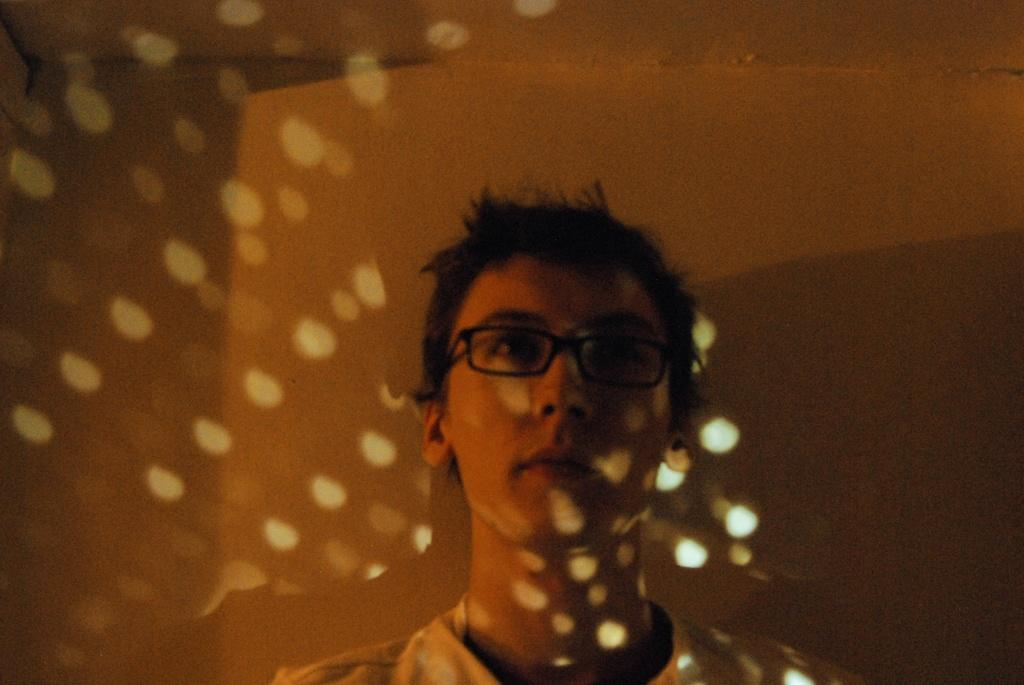Who is present in the image? There is a man in the picture. What is the man wearing in the image? The man is wearing spectacles. What can be seen in the background of the image? There is a wall visible in the background of the picture. What might be the source of the reflection in the image? There appears to be a reflection of lights in the image. What type of suit is the man wearing in the image? The provided facts do not mention a suit; the man is only described as wearing spectacles. How many times does the man turn around in the image? There is no indication in the image that the man is turning around, so it cannot be determined from the picture. 